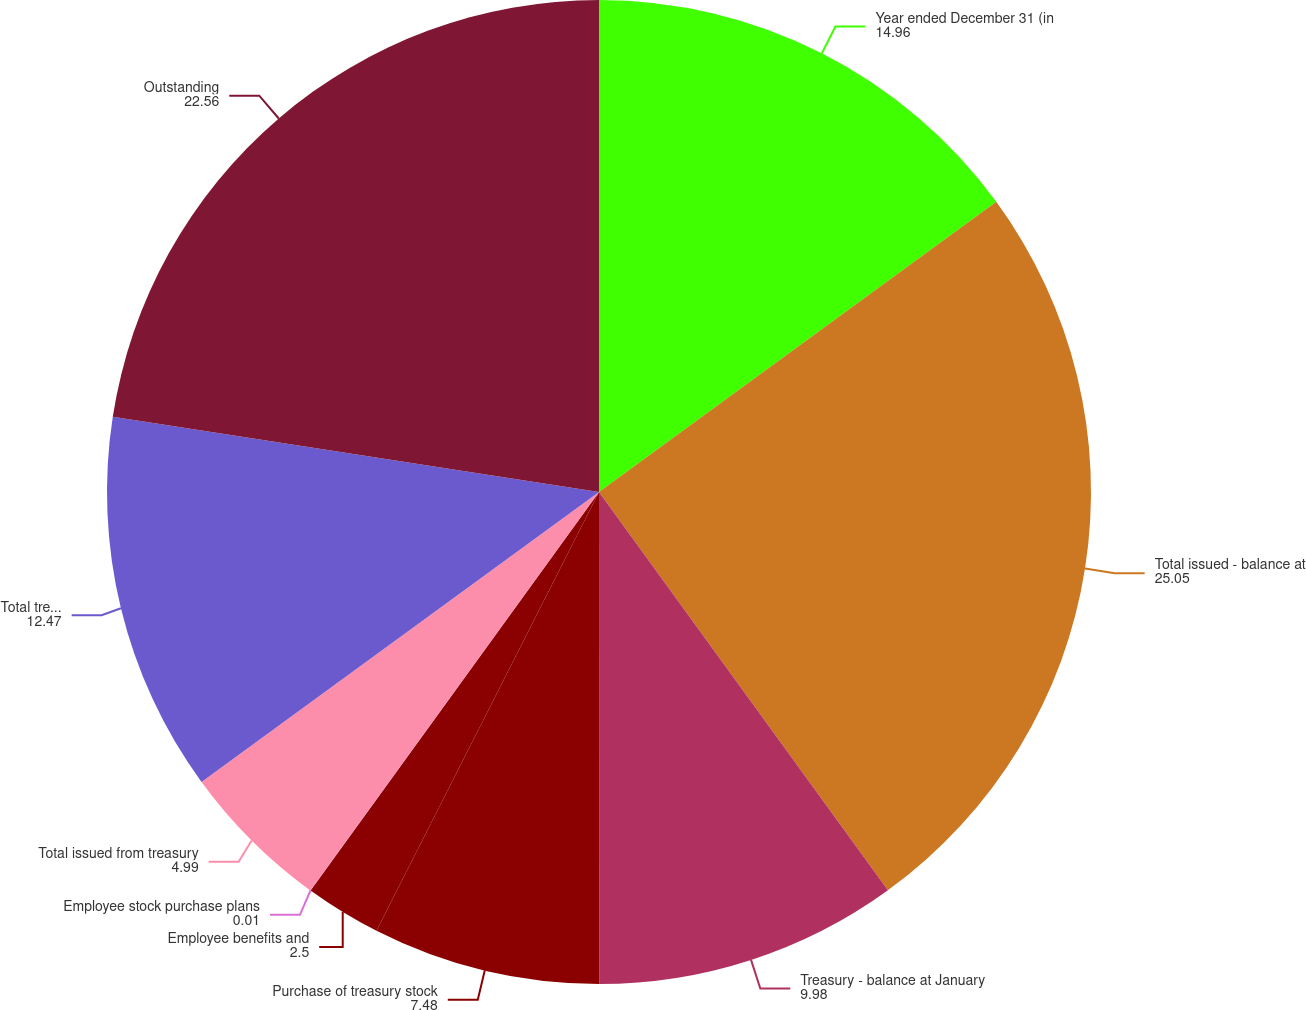<chart> <loc_0><loc_0><loc_500><loc_500><pie_chart><fcel>Year ended December 31 (in<fcel>Total issued - balance at<fcel>Treasury - balance at January<fcel>Purchase of treasury stock<fcel>Employee benefits and<fcel>Employee stock purchase plans<fcel>Total issued from treasury<fcel>Total treasury - balance at<fcel>Outstanding<nl><fcel>14.96%<fcel>25.05%<fcel>9.98%<fcel>7.48%<fcel>2.5%<fcel>0.01%<fcel>4.99%<fcel>12.47%<fcel>22.56%<nl></chart> 